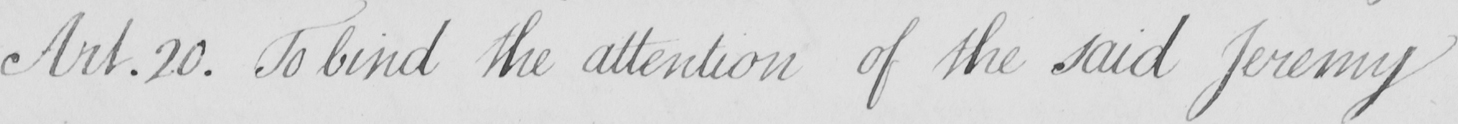Please transcribe the handwritten text in this image. Art.20 . To bind the attention of the said Jeremy 